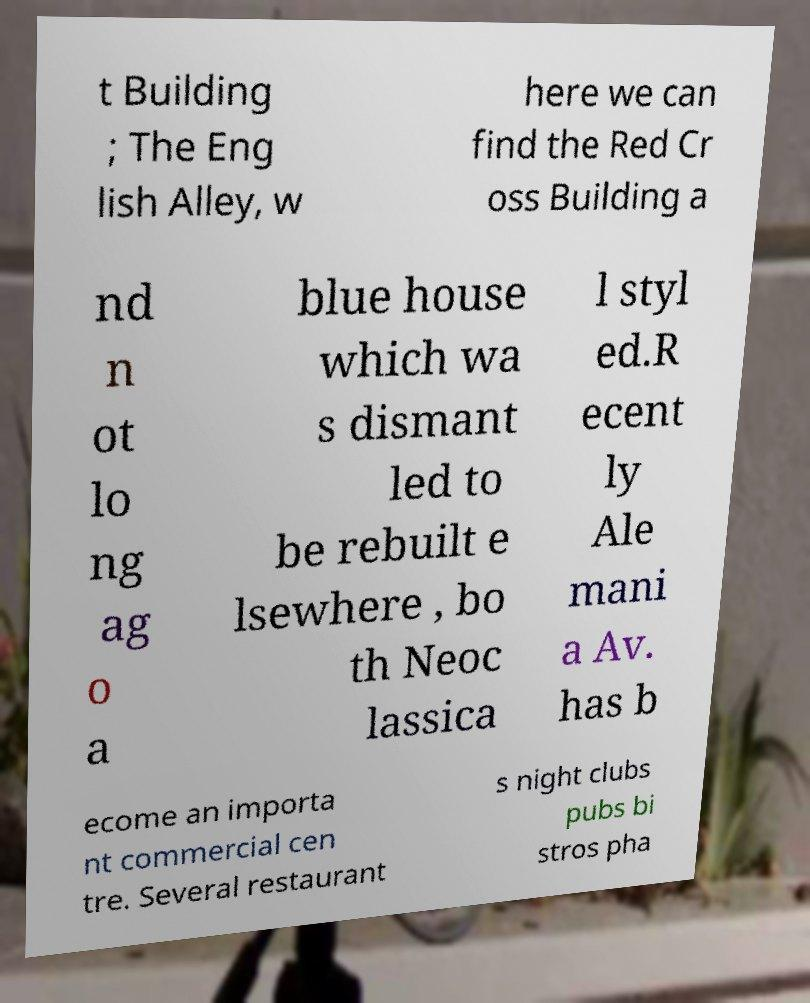There's text embedded in this image that I need extracted. Can you transcribe it verbatim? t Building ; The Eng lish Alley, w here we can find the Red Cr oss Building a nd n ot lo ng ag o a blue house which wa s dismant led to be rebuilt e lsewhere , bo th Neoc lassica l styl ed.R ecent ly Ale mani a Av. has b ecome an importa nt commercial cen tre. Several restaurant s night clubs pubs bi stros pha 